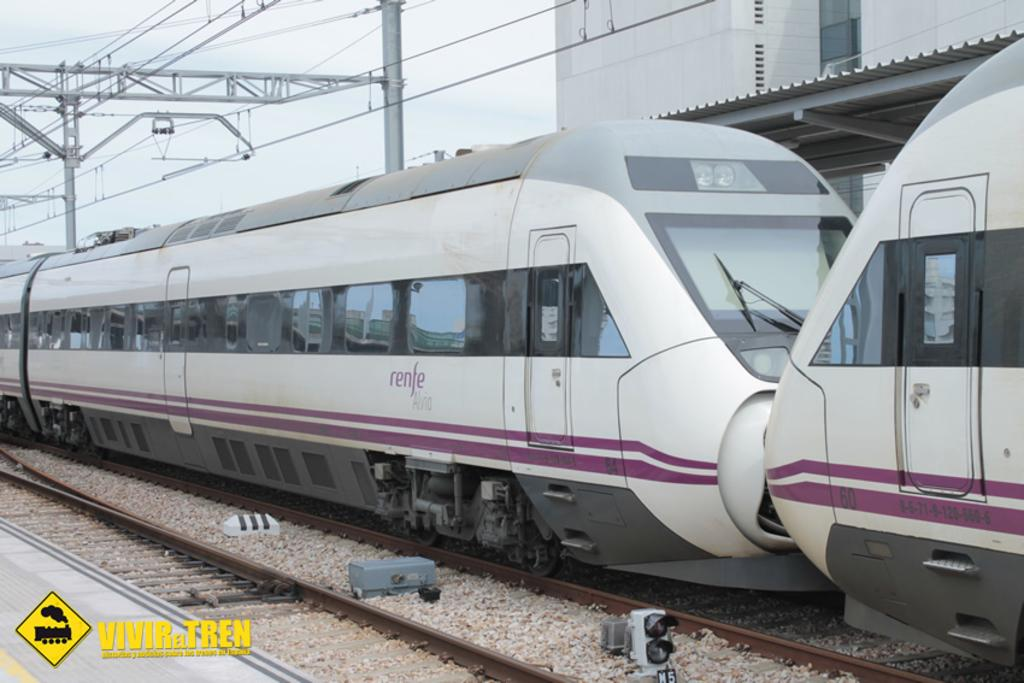<image>
Relay a brief, clear account of the picture shown. A sleek looking train with the caption Vivir el Tren posted beneath of it. 